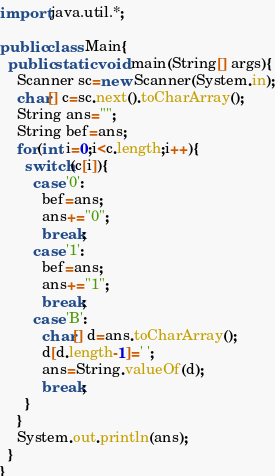<code> <loc_0><loc_0><loc_500><loc_500><_Java_>import java.util.*;

public class Main{
  public static void main(String[] args){
    Scanner sc=new Scanner(System.in);
    char[] c=sc.next().toCharArray();
    String ans="";
    String bef=ans;
    for(int i=0;i<c.length;i++){
      switch(c[i]){
        case '0':
          bef=ans;
          ans+="0";
          break;
        case '1':
          bef=ans;
          ans+="1";
          break;
        case 'B':
          char[] d=ans.toCharArray();
          d[d.length-1]=' ';
          ans=String.valueOf(d);
          break;
      }
    }
    System.out.println(ans);
  }
}</code> 